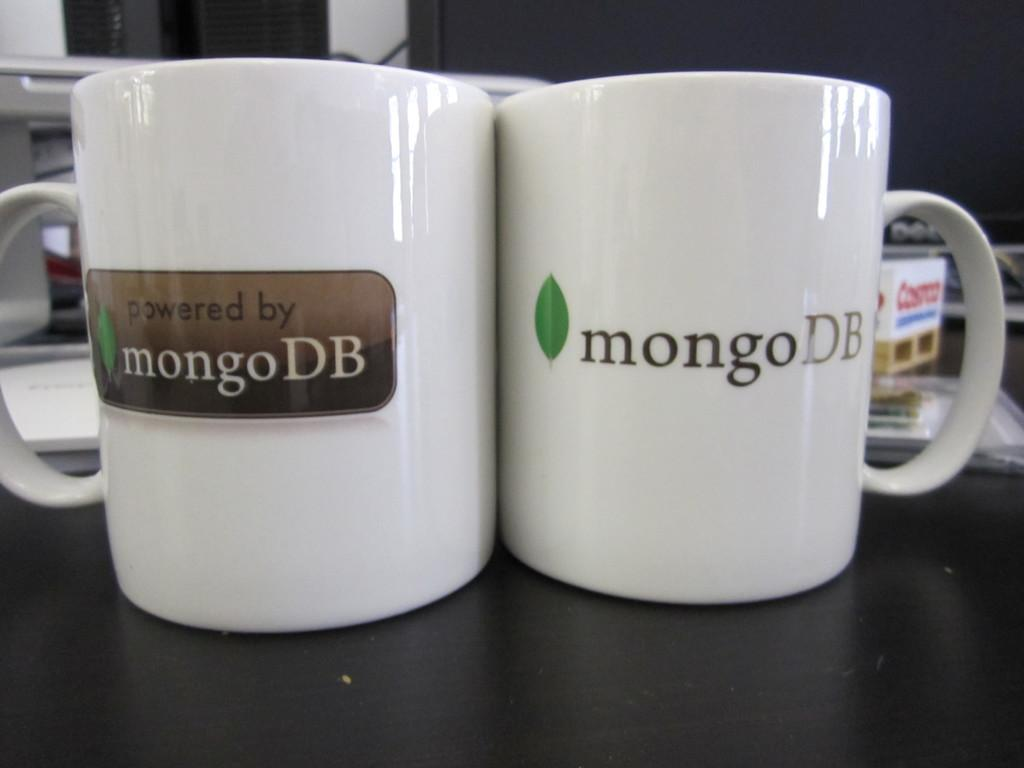<image>
Share a concise interpretation of the image provided. Two white mugs that say mongo DB on them. 